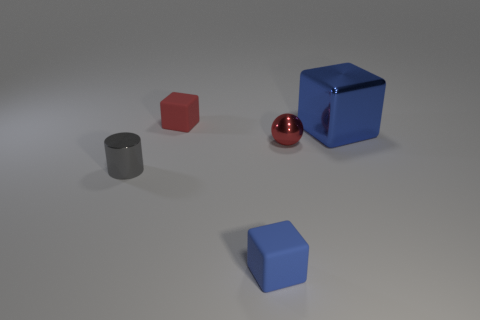Which objects have a shinier surface? The objects with shinier surfaces are the large blue cube and the red sphere. These objects reflect light and the environment more prominently than the other objects, which have a matte finish.  How would you describe the lighting in the scene? The lighting appears to be soft and diffused, with a relatively uniform illumination across the scene. There are subtle shadows cast by the objects, indicating a light source located above the objects, likely out of the frame. The soft-edged shadows suggest the light source is not very harsh or direct. 